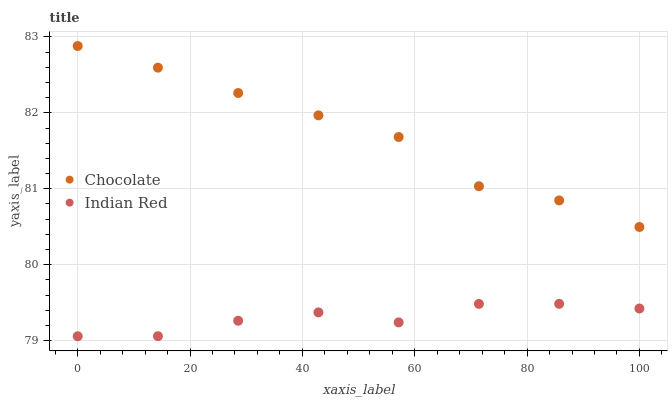Does Indian Red have the minimum area under the curve?
Answer yes or no. Yes. Does Chocolate have the maximum area under the curve?
Answer yes or no. Yes. Does Chocolate have the minimum area under the curve?
Answer yes or no. No. Is Chocolate the smoothest?
Answer yes or no. Yes. Is Indian Red the roughest?
Answer yes or no. Yes. Is Chocolate the roughest?
Answer yes or no. No. Does Indian Red have the lowest value?
Answer yes or no. Yes. Does Chocolate have the lowest value?
Answer yes or no. No. Does Chocolate have the highest value?
Answer yes or no. Yes. Is Indian Red less than Chocolate?
Answer yes or no. Yes. Is Chocolate greater than Indian Red?
Answer yes or no. Yes. Does Indian Red intersect Chocolate?
Answer yes or no. No. 